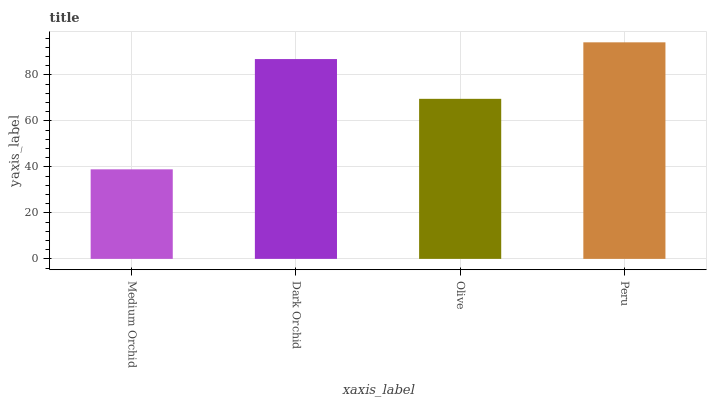Is Medium Orchid the minimum?
Answer yes or no. Yes. Is Peru the maximum?
Answer yes or no. Yes. Is Dark Orchid the minimum?
Answer yes or no. No. Is Dark Orchid the maximum?
Answer yes or no. No. Is Dark Orchid greater than Medium Orchid?
Answer yes or no. Yes. Is Medium Orchid less than Dark Orchid?
Answer yes or no. Yes. Is Medium Orchid greater than Dark Orchid?
Answer yes or no. No. Is Dark Orchid less than Medium Orchid?
Answer yes or no. No. Is Dark Orchid the high median?
Answer yes or no. Yes. Is Olive the low median?
Answer yes or no. Yes. Is Olive the high median?
Answer yes or no. No. Is Peru the low median?
Answer yes or no. No. 